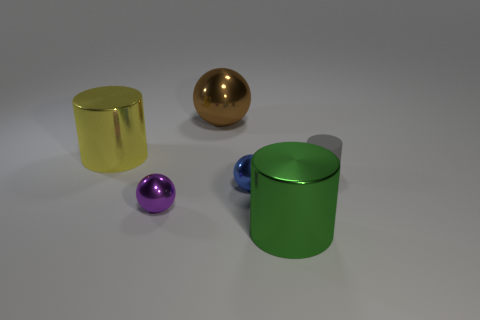Is the large green thing made of the same material as the gray object?
Your answer should be compact. No. What color is the thing that is both behind the gray rubber cylinder and in front of the large sphere?
Give a very brief answer. Yellow. Is there a thing behind the large metallic cylinder that is behind the green cylinder?
Ensure brevity in your answer.  Yes. Is the number of large brown spheres that are in front of the big brown object the same as the number of purple metallic things?
Provide a succinct answer. No. There is a shiny cylinder behind the matte thing on the right side of the small blue thing; how many big yellow metallic cylinders are to the left of it?
Your answer should be very brief. 0. Are there any red metal cubes of the same size as the blue ball?
Make the answer very short. No. Is the number of metal cylinders that are behind the gray rubber object less than the number of gray things?
Provide a succinct answer. No. What material is the tiny gray cylinder that is in front of the cylinder that is on the left side of the big metallic cylinder that is in front of the tiny purple sphere made of?
Give a very brief answer. Rubber. Are there more tiny gray rubber objects on the right side of the big brown metal object than small cylinders that are on the left side of the gray thing?
Your answer should be compact. Yes. What number of metallic things are gray objects or cylinders?
Make the answer very short. 2. 